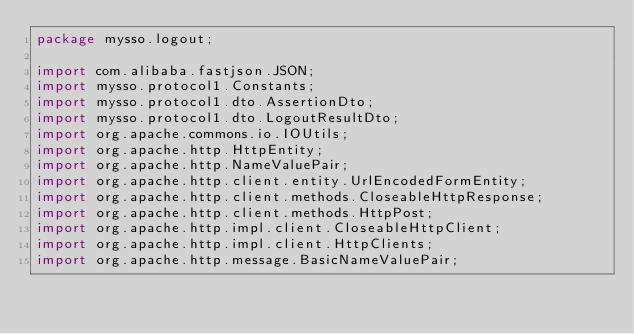Convert code to text. <code><loc_0><loc_0><loc_500><loc_500><_Java_>package mysso.logout;

import com.alibaba.fastjson.JSON;
import mysso.protocol1.Constants;
import mysso.protocol1.dto.AssertionDto;
import mysso.protocol1.dto.LogoutResultDto;
import org.apache.commons.io.IOUtils;
import org.apache.http.HttpEntity;
import org.apache.http.NameValuePair;
import org.apache.http.client.entity.UrlEncodedFormEntity;
import org.apache.http.client.methods.CloseableHttpResponse;
import org.apache.http.client.methods.HttpPost;
import org.apache.http.impl.client.CloseableHttpClient;
import org.apache.http.impl.client.HttpClients;
import org.apache.http.message.BasicNameValuePair;</code> 